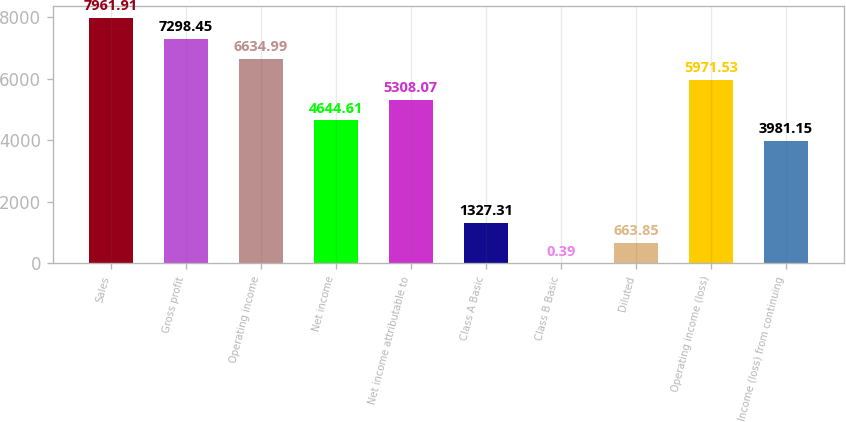Convert chart. <chart><loc_0><loc_0><loc_500><loc_500><bar_chart><fcel>Sales<fcel>Gross profit<fcel>Operating income<fcel>Net income<fcel>Net income attributable to<fcel>Class A Basic<fcel>Class B Basic<fcel>Diluted<fcel>Operating income (loss)<fcel>Income (loss) from continuing<nl><fcel>7961.91<fcel>7298.45<fcel>6634.99<fcel>4644.61<fcel>5308.07<fcel>1327.31<fcel>0.39<fcel>663.85<fcel>5971.53<fcel>3981.15<nl></chart> 